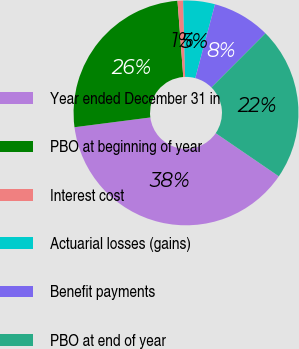Convert chart to OTSL. <chart><loc_0><loc_0><loc_500><loc_500><pie_chart><fcel>Year ended December 31 in<fcel>PBO at beginning of year<fcel>Interest cost<fcel>Actuarial losses (gains)<fcel>Benefit payments<fcel>PBO at end of year<nl><fcel>38.42%<fcel>25.83%<fcel>0.8%<fcel>4.56%<fcel>8.33%<fcel>22.06%<nl></chart> 